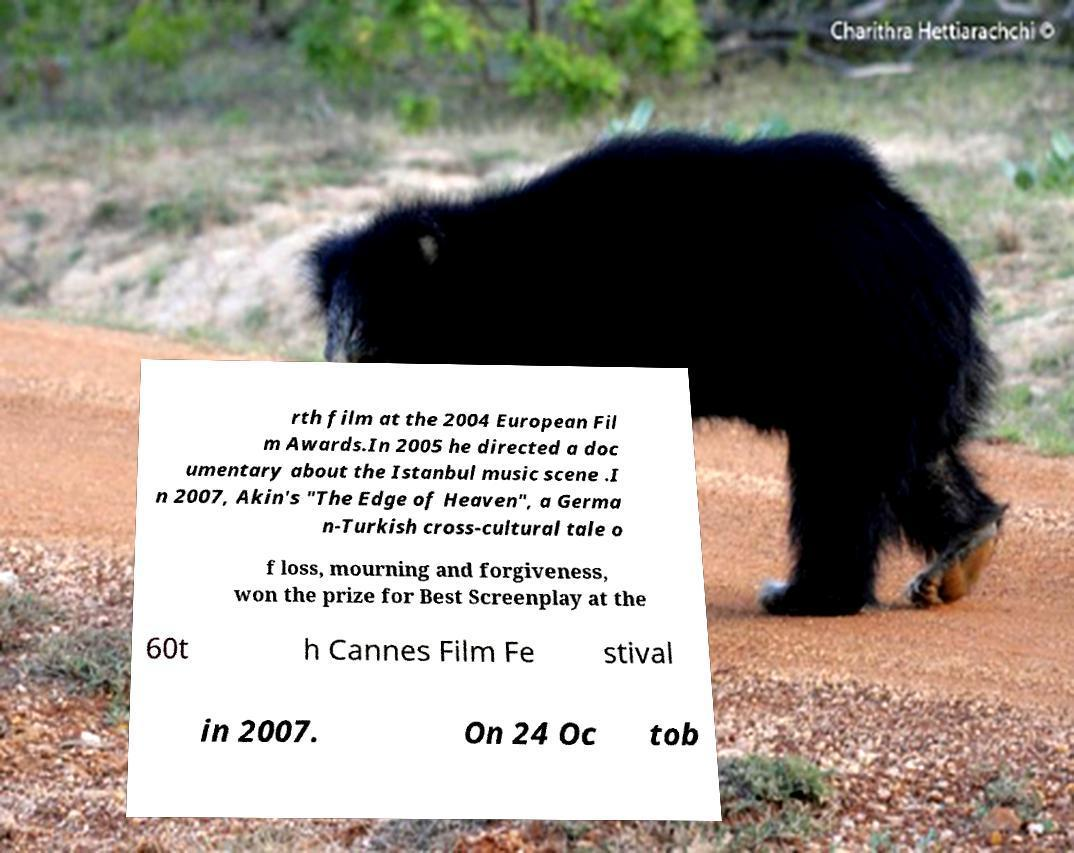Please read and relay the text visible in this image. What does it say? rth film at the 2004 European Fil m Awards.In 2005 he directed a doc umentary about the Istanbul music scene .I n 2007, Akin's "The Edge of Heaven", a Germa n-Turkish cross-cultural tale o f loss, mourning and forgiveness, won the prize for Best Screenplay at the 60t h Cannes Film Fe stival in 2007. On 24 Oc tob 